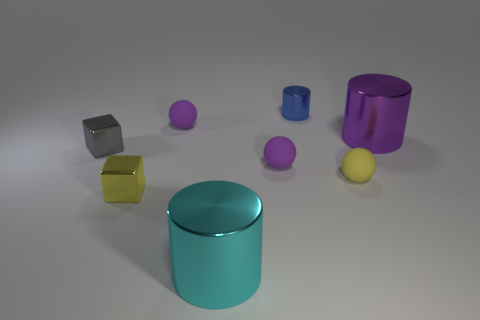Which objects in the image seem like they could contain something inside, and why? The cylinders and the hollow purple cube have the potential to hold items inside due to their shapes. The cylinders have an open top, while the hollow cube has a visible cavity. These characteristics suggest their utility as containers, possibly serving functional or decorative purposes. 